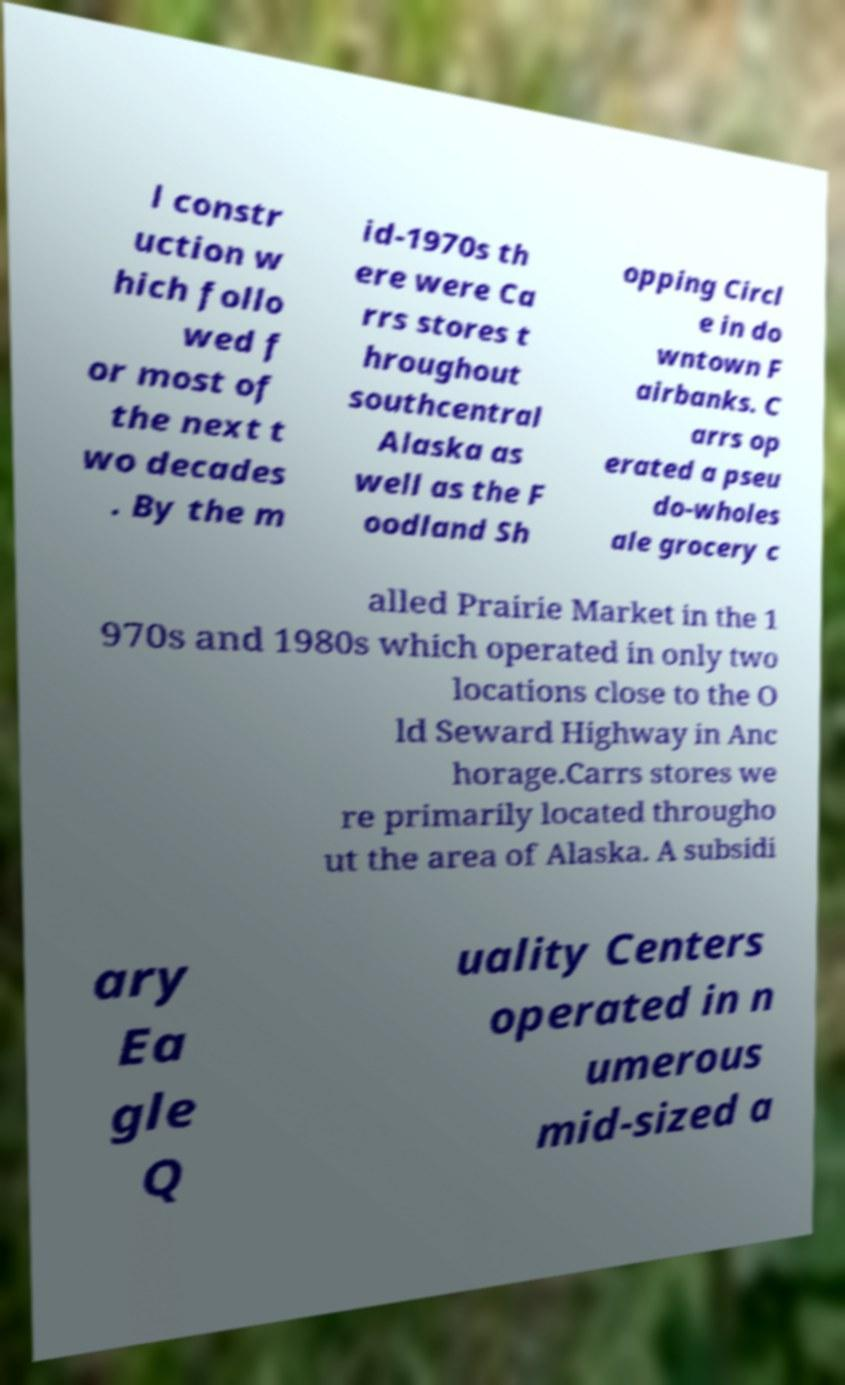I need the written content from this picture converted into text. Can you do that? l constr uction w hich follo wed f or most of the next t wo decades . By the m id-1970s th ere were Ca rrs stores t hroughout southcentral Alaska as well as the F oodland Sh opping Circl e in do wntown F airbanks. C arrs op erated a pseu do-wholes ale grocery c alled Prairie Market in the 1 970s and 1980s which operated in only two locations close to the O ld Seward Highway in Anc horage.Carrs stores we re primarily located througho ut the area of Alaska. A subsidi ary Ea gle Q uality Centers operated in n umerous mid-sized a 